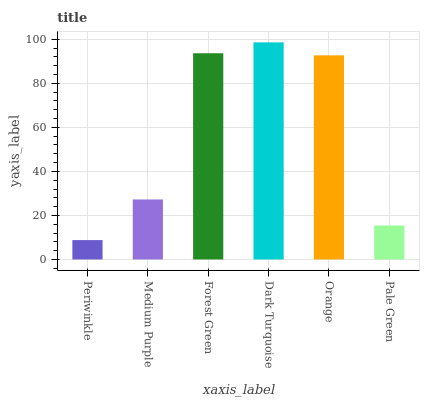Is Periwinkle the minimum?
Answer yes or no. Yes. Is Dark Turquoise the maximum?
Answer yes or no. Yes. Is Medium Purple the minimum?
Answer yes or no. No. Is Medium Purple the maximum?
Answer yes or no. No. Is Medium Purple greater than Periwinkle?
Answer yes or no. Yes. Is Periwinkle less than Medium Purple?
Answer yes or no. Yes. Is Periwinkle greater than Medium Purple?
Answer yes or no. No. Is Medium Purple less than Periwinkle?
Answer yes or no. No. Is Orange the high median?
Answer yes or no. Yes. Is Medium Purple the low median?
Answer yes or no. Yes. Is Periwinkle the high median?
Answer yes or no. No. Is Forest Green the low median?
Answer yes or no. No. 